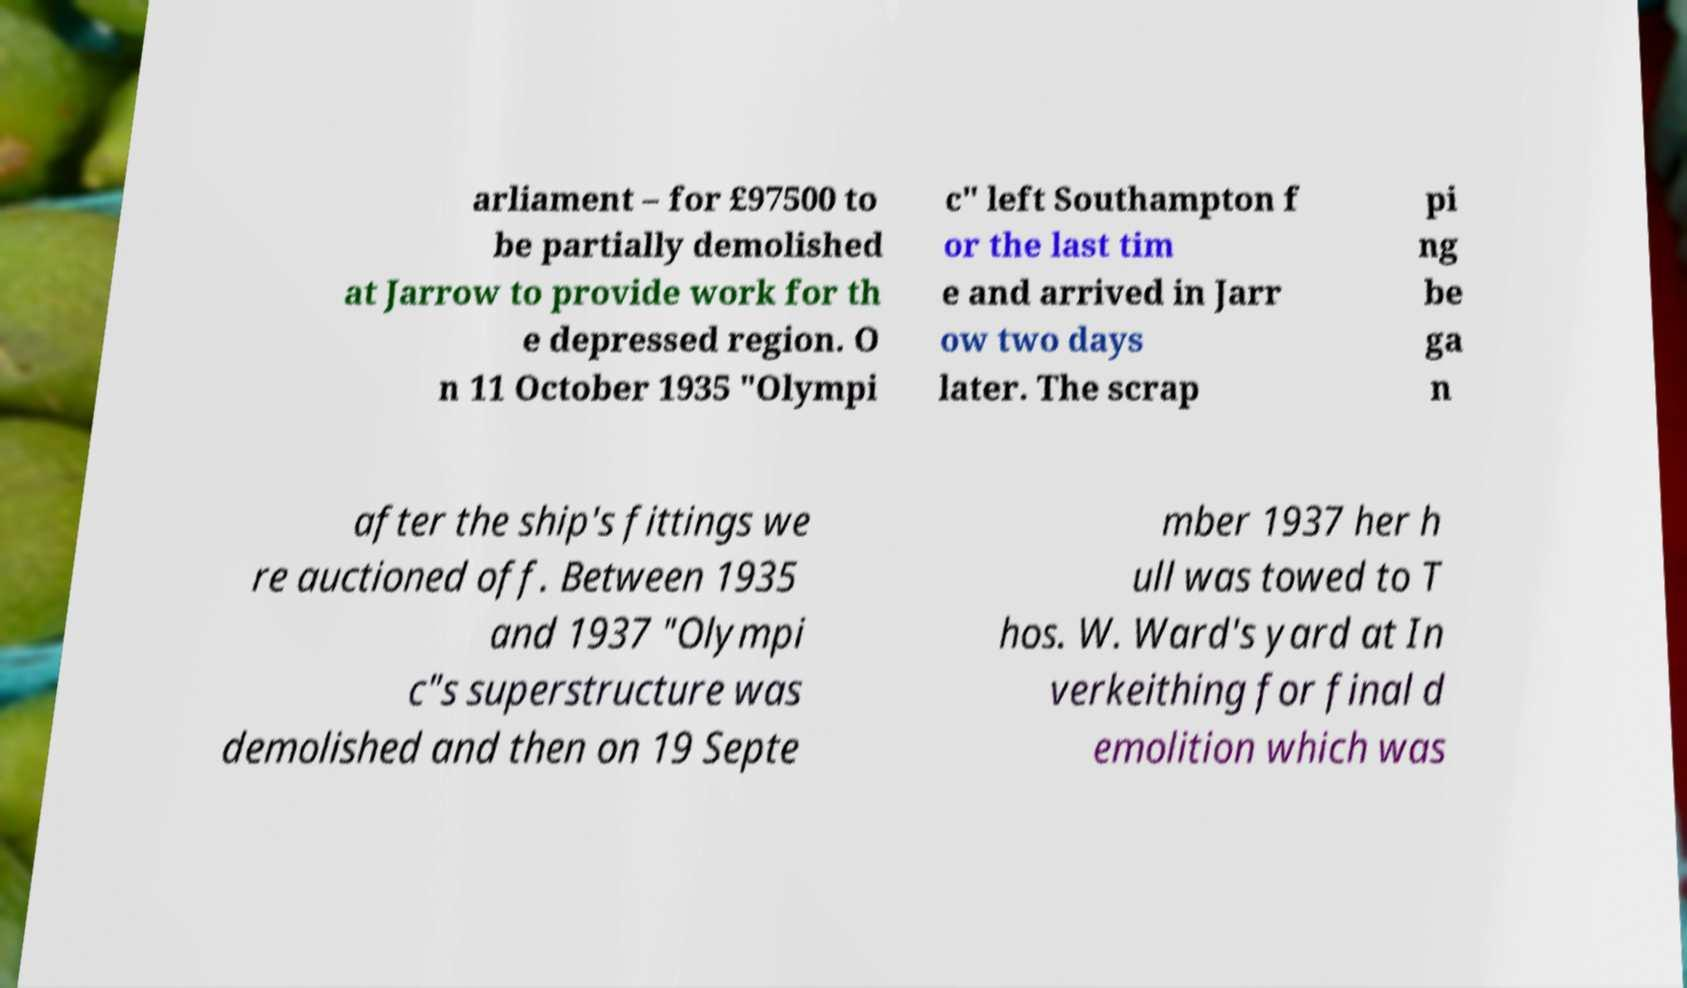What messages or text are displayed in this image? I need them in a readable, typed format. arliament – for £97500 to be partially demolished at Jarrow to provide work for th e depressed region. O n 11 October 1935 "Olympi c" left Southampton f or the last tim e and arrived in Jarr ow two days later. The scrap pi ng be ga n after the ship's fittings we re auctioned off. Between 1935 and 1937 "Olympi c"s superstructure was demolished and then on 19 Septe mber 1937 her h ull was towed to T hos. W. Ward's yard at In verkeithing for final d emolition which was 